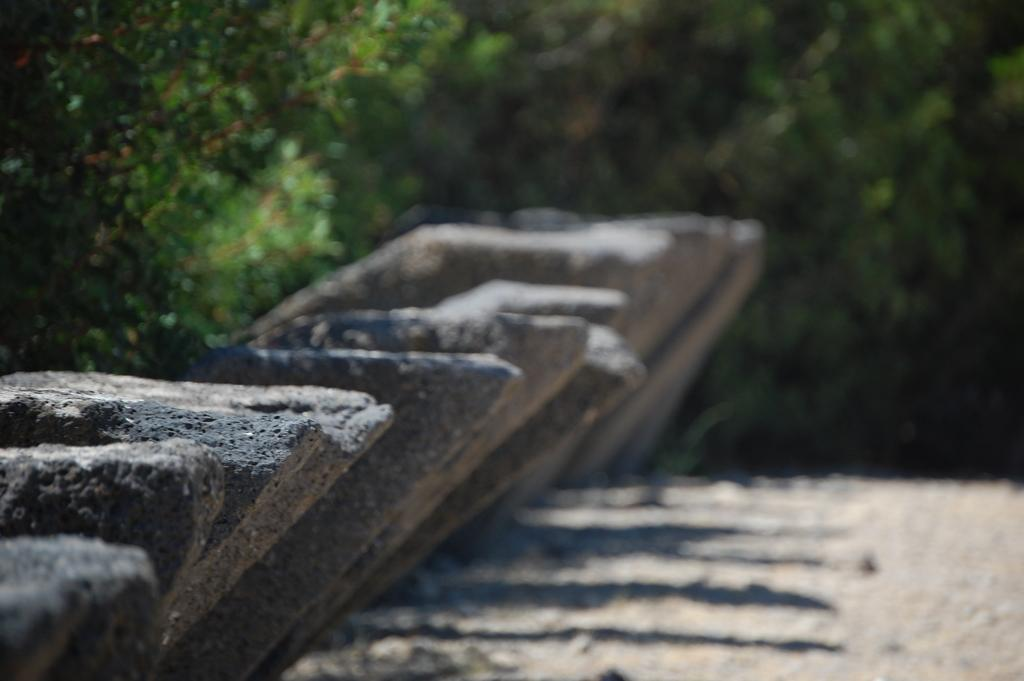What type of material is used for the logs in the image? The logs in the front of the image are made of wood. What can be seen in the background of the image? There are trees in the background of the image. Is there a horse using bait to attack the wooden logs in the image? There is no horse or any form of attack present in the image. The image only features wooden logs and trees. 